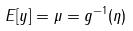Convert formula to latex. <formula><loc_0><loc_0><loc_500><loc_500>E [ y ] = \mu = g ^ { - 1 } ( \eta )</formula> 